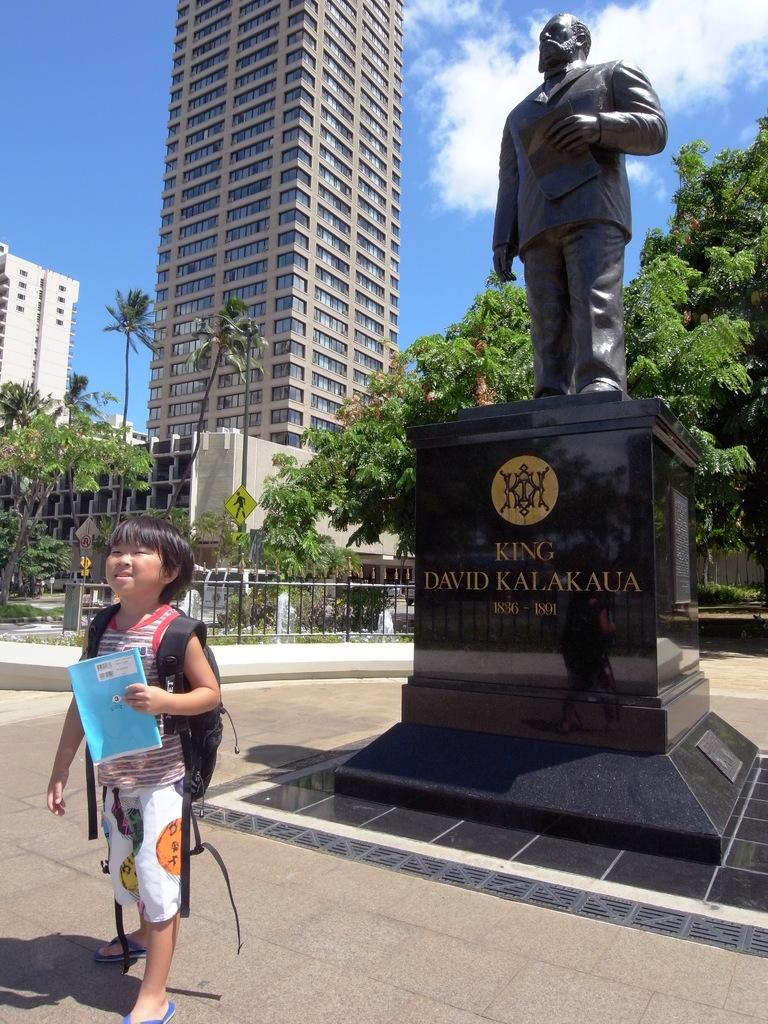What is the main subject of the image? The main subject of the image is a child. What is the child doing in the image? The child is standing in the image. What is the child holding in their hand? The child is holding a book in their hand. What else is the child carrying in the image? The child is carrying a bag. What can be seen in the background of the image? There are trees, a fence, a statue, buildings, and the sky visible in the background of the image. What is the condition of the child's eye in the image? There is no information about the child's eye condition in the image. What type of border is present around the image? The provided facts do not mention any border around the image. 